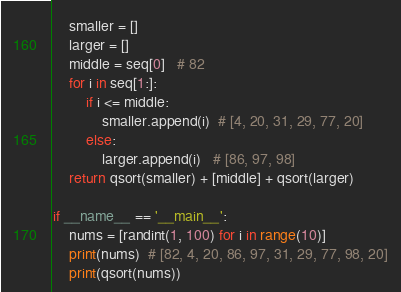<code> <loc_0><loc_0><loc_500><loc_500><_Python_>    smaller = []
    larger = []
    middle = seq[0]   # 82
    for i in seq[1:]:
        if i <= middle:
            smaller.append(i)  # [4, 20, 31, 29, 77, 20]
        else:
            larger.append(i)   # [86, 97, 98]
    return qsort(smaller) + [middle] + qsort(larger)

if __name__ == '__main__':
    nums = [randint(1, 100) for i in range(10)]
    print(nums)  # [82, 4, 20, 86, 97, 31, 29, 77, 98, 20]
    print(qsort(nums))
</code> 